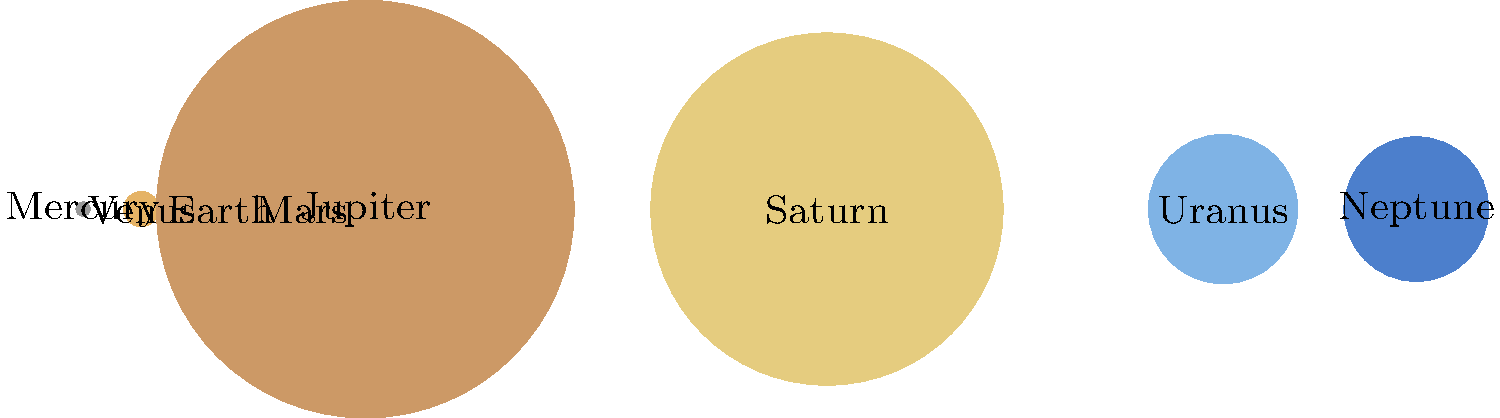As you plan for your retirement investments, consider this astronomy question to exercise your analytical skills: The image shows the relative sizes of planets in our solar system. Which planet has a diameter closest to twice that of Earth? Let's approach this step-by-step:

1. The diameters of the planets are represented by the diameters of the circles in the image.

2. We need to find the planet with a diameter closest to twice that of Earth.

3. Earth's diameter is represented by the third circle from the left.

4. To find a planet with twice Earth's diameter, we need to look for a circle with roughly twice the diameter of Earth's circle.

5. Visually inspecting the image, we can see that Uranus and Neptune (the two rightmost planets) appear to be closest to twice Earth's size.

6. To be more precise, let's compare the actual diameters:
   Earth's diameter: 12,742 km
   Uranus' diameter: 51,118 km
   Neptune's diameter: 49,528 km

7. Twice Earth's diameter would be: 12,742 * 2 = 25,484 km

8. Comparing the differences:
   Uranus: |51,118 - 25,484| = 25,634 km
   Neptune: |49,528 - 25,484| = 24,044 km

9. Neptune's diameter is closer to twice Earth's diameter than Uranus'.

Therefore, Neptune is the planet with a diameter closest to twice that of Earth.
Answer: Neptune 